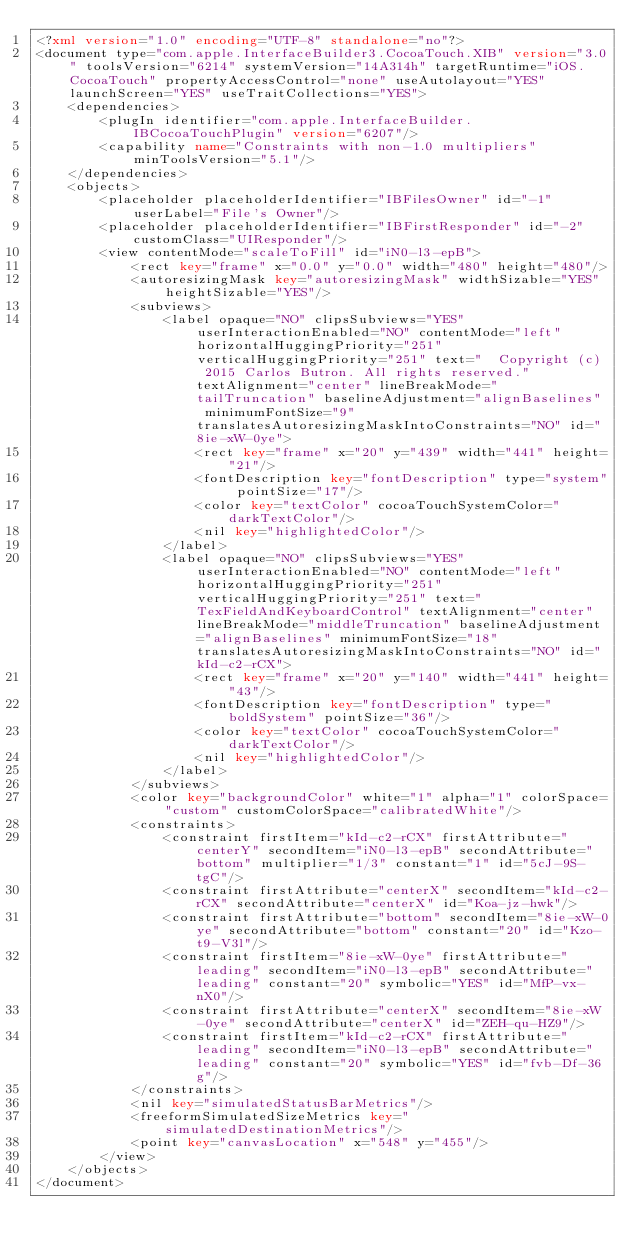<code> <loc_0><loc_0><loc_500><loc_500><_XML_><?xml version="1.0" encoding="UTF-8" standalone="no"?>
<document type="com.apple.InterfaceBuilder3.CocoaTouch.XIB" version="3.0" toolsVersion="6214" systemVersion="14A314h" targetRuntime="iOS.CocoaTouch" propertyAccessControl="none" useAutolayout="YES" launchScreen="YES" useTraitCollections="YES">
    <dependencies>
        <plugIn identifier="com.apple.InterfaceBuilder.IBCocoaTouchPlugin" version="6207"/>
        <capability name="Constraints with non-1.0 multipliers" minToolsVersion="5.1"/>
    </dependencies>
    <objects>
        <placeholder placeholderIdentifier="IBFilesOwner" id="-1" userLabel="File's Owner"/>
        <placeholder placeholderIdentifier="IBFirstResponder" id="-2" customClass="UIResponder"/>
        <view contentMode="scaleToFill" id="iN0-l3-epB">
            <rect key="frame" x="0.0" y="0.0" width="480" height="480"/>
            <autoresizingMask key="autoresizingMask" widthSizable="YES" heightSizable="YES"/>
            <subviews>
                <label opaque="NO" clipsSubviews="YES" userInteractionEnabled="NO" contentMode="left" horizontalHuggingPriority="251" verticalHuggingPriority="251" text="  Copyright (c) 2015 Carlos Butron. All rights reserved." textAlignment="center" lineBreakMode="tailTruncation" baselineAdjustment="alignBaselines" minimumFontSize="9" translatesAutoresizingMaskIntoConstraints="NO" id="8ie-xW-0ye">
                    <rect key="frame" x="20" y="439" width="441" height="21"/>
                    <fontDescription key="fontDescription" type="system" pointSize="17"/>
                    <color key="textColor" cocoaTouchSystemColor="darkTextColor"/>
                    <nil key="highlightedColor"/>
                </label>
                <label opaque="NO" clipsSubviews="YES" userInteractionEnabled="NO" contentMode="left" horizontalHuggingPriority="251" verticalHuggingPriority="251" text="TexFieldAndKeyboardControl" textAlignment="center" lineBreakMode="middleTruncation" baselineAdjustment="alignBaselines" minimumFontSize="18" translatesAutoresizingMaskIntoConstraints="NO" id="kId-c2-rCX">
                    <rect key="frame" x="20" y="140" width="441" height="43"/>
                    <fontDescription key="fontDescription" type="boldSystem" pointSize="36"/>
                    <color key="textColor" cocoaTouchSystemColor="darkTextColor"/>
                    <nil key="highlightedColor"/>
                </label>
            </subviews>
            <color key="backgroundColor" white="1" alpha="1" colorSpace="custom" customColorSpace="calibratedWhite"/>
            <constraints>
                <constraint firstItem="kId-c2-rCX" firstAttribute="centerY" secondItem="iN0-l3-epB" secondAttribute="bottom" multiplier="1/3" constant="1" id="5cJ-9S-tgC"/>
                <constraint firstAttribute="centerX" secondItem="kId-c2-rCX" secondAttribute="centerX" id="Koa-jz-hwk"/>
                <constraint firstAttribute="bottom" secondItem="8ie-xW-0ye" secondAttribute="bottom" constant="20" id="Kzo-t9-V3l"/>
                <constraint firstItem="8ie-xW-0ye" firstAttribute="leading" secondItem="iN0-l3-epB" secondAttribute="leading" constant="20" symbolic="YES" id="MfP-vx-nX0"/>
                <constraint firstAttribute="centerX" secondItem="8ie-xW-0ye" secondAttribute="centerX" id="ZEH-qu-HZ9"/>
                <constraint firstItem="kId-c2-rCX" firstAttribute="leading" secondItem="iN0-l3-epB" secondAttribute="leading" constant="20" symbolic="YES" id="fvb-Df-36g"/>
            </constraints>
            <nil key="simulatedStatusBarMetrics"/>
            <freeformSimulatedSizeMetrics key="simulatedDestinationMetrics"/>
            <point key="canvasLocation" x="548" y="455"/>
        </view>
    </objects>
</document>
</code> 